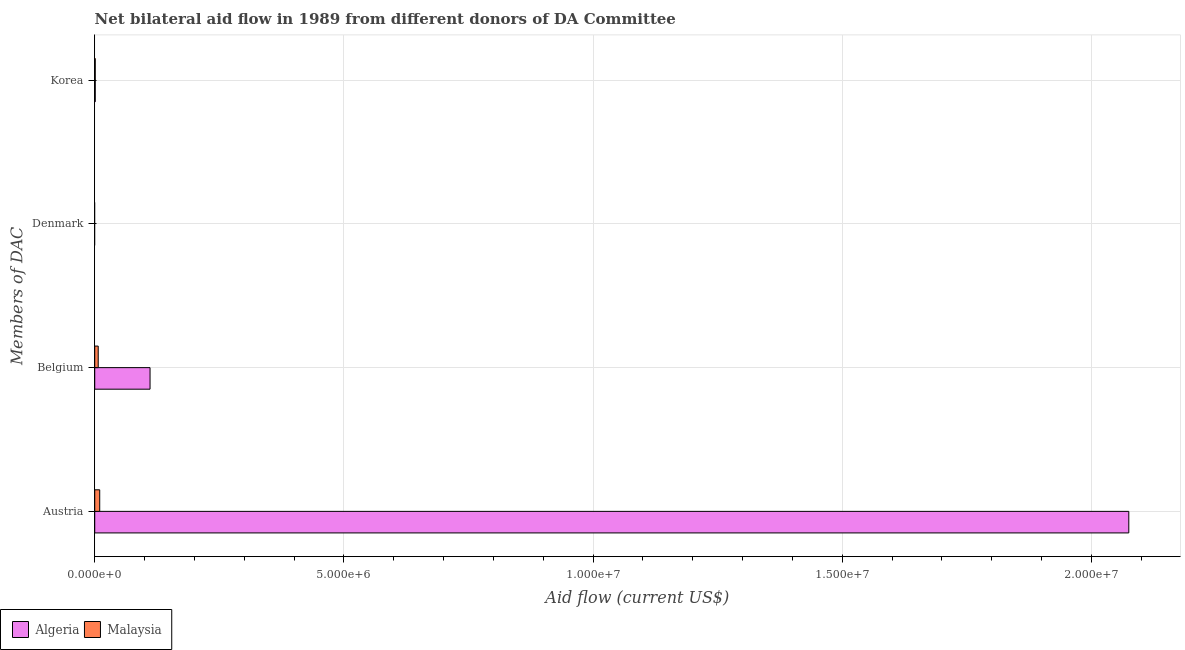How many different coloured bars are there?
Offer a very short reply. 2. Are the number of bars per tick equal to the number of legend labels?
Offer a terse response. No. Are the number of bars on each tick of the Y-axis equal?
Provide a succinct answer. No. How many bars are there on the 3rd tick from the top?
Offer a very short reply. 2. How many bars are there on the 3rd tick from the bottom?
Provide a succinct answer. 0. What is the amount of aid given by belgium in Malaysia?
Your answer should be compact. 7.00e+04. Across all countries, what is the maximum amount of aid given by korea?
Your response must be concise. 10000. Across all countries, what is the minimum amount of aid given by belgium?
Ensure brevity in your answer.  7.00e+04. In which country was the amount of aid given by korea maximum?
Keep it short and to the point. Algeria. What is the total amount of aid given by korea in the graph?
Your answer should be very brief. 2.00e+04. What is the difference between the amount of aid given by austria in Malaysia and that in Algeria?
Provide a succinct answer. -2.06e+07. What is the difference between the amount of aid given by denmark in Malaysia and the amount of aid given by austria in Algeria?
Ensure brevity in your answer.  -2.08e+07. What is the difference between the amount of aid given by belgium and amount of aid given by korea in Algeria?
Your answer should be compact. 1.10e+06. In how many countries, is the amount of aid given by korea greater than 13000000 US$?
Provide a short and direct response. 0. What is the ratio of the amount of aid given by korea in Malaysia to that in Algeria?
Provide a short and direct response. 1. Is the difference between the amount of aid given by austria in Malaysia and Algeria greater than the difference between the amount of aid given by korea in Malaysia and Algeria?
Provide a succinct answer. No. What is the difference between the highest and the second highest amount of aid given by korea?
Your answer should be very brief. 0. What is the difference between the highest and the lowest amount of aid given by belgium?
Offer a terse response. 1.04e+06. How many bars are there?
Your response must be concise. 6. Are all the bars in the graph horizontal?
Offer a very short reply. Yes. Does the graph contain any zero values?
Your answer should be compact. Yes. Does the graph contain grids?
Give a very brief answer. Yes. What is the title of the graph?
Ensure brevity in your answer.  Net bilateral aid flow in 1989 from different donors of DA Committee. What is the label or title of the Y-axis?
Offer a terse response. Members of DAC. What is the Aid flow (current US$) in Algeria in Austria?
Your answer should be very brief. 2.08e+07. What is the Aid flow (current US$) of Algeria in Belgium?
Your response must be concise. 1.11e+06. What is the Aid flow (current US$) in Algeria in Korea?
Keep it short and to the point. 10000. What is the Aid flow (current US$) in Malaysia in Korea?
Keep it short and to the point. 10000. Across all Members of DAC, what is the maximum Aid flow (current US$) of Algeria?
Your answer should be compact. 2.08e+07. Across all Members of DAC, what is the maximum Aid flow (current US$) of Malaysia?
Make the answer very short. 1.00e+05. What is the total Aid flow (current US$) in Algeria in the graph?
Your answer should be compact. 2.19e+07. What is the total Aid flow (current US$) of Malaysia in the graph?
Keep it short and to the point. 1.80e+05. What is the difference between the Aid flow (current US$) in Algeria in Austria and that in Belgium?
Keep it short and to the point. 1.96e+07. What is the difference between the Aid flow (current US$) of Malaysia in Austria and that in Belgium?
Make the answer very short. 3.00e+04. What is the difference between the Aid flow (current US$) of Algeria in Austria and that in Korea?
Offer a very short reply. 2.07e+07. What is the difference between the Aid flow (current US$) in Malaysia in Austria and that in Korea?
Provide a succinct answer. 9.00e+04. What is the difference between the Aid flow (current US$) in Algeria in Belgium and that in Korea?
Keep it short and to the point. 1.10e+06. What is the difference between the Aid flow (current US$) in Malaysia in Belgium and that in Korea?
Keep it short and to the point. 6.00e+04. What is the difference between the Aid flow (current US$) in Algeria in Austria and the Aid flow (current US$) in Malaysia in Belgium?
Offer a very short reply. 2.07e+07. What is the difference between the Aid flow (current US$) in Algeria in Austria and the Aid flow (current US$) in Malaysia in Korea?
Ensure brevity in your answer.  2.07e+07. What is the difference between the Aid flow (current US$) in Algeria in Belgium and the Aid flow (current US$) in Malaysia in Korea?
Provide a short and direct response. 1.10e+06. What is the average Aid flow (current US$) of Algeria per Members of DAC?
Ensure brevity in your answer.  5.47e+06. What is the average Aid flow (current US$) of Malaysia per Members of DAC?
Give a very brief answer. 4.50e+04. What is the difference between the Aid flow (current US$) in Algeria and Aid flow (current US$) in Malaysia in Austria?
Ensure brevity in your answer.  2.06e+07. What is the difference between the Aid flow (current US$) of Algeria and Aid flow (current US$) of Malaysia in Belgium?
Provide a succinct answer. 1.04e+06. What is the difference between the Aid flow (current US$) in Algeria and Aid flow (current US$) in Malaysia in Korea?
Give a very brief answer. 0. What is the ratio of the Aid flow (current US$) in Algeria in Austria to that in Belgium?
Make the answer very short. 18.69. What is the ratio of the Aid flow (current US$) in Malaysia in Austria to that in Belgium?
Provide a succinct answer. 1.43. What is the ratio of the Aid flow (current US$) in Algeria in Austria to that in Korea?
Provide a succinct answer. 2075. What is the ratio of the Aid flow (current US$) of Algeria in Belgium to that in Korea?
Give a very brief answer. 111. What is the ratio of the Aid flow (current US$) in Malaysia in Belgium to that in Korea?
Your answer should be very brief. 7. What is the difference between the highest and the second highest Aid flow (current US$) of Algeria?
Provide a short and direct response. 1.96e+07. What is the difference between the highest and the lowest Aid flow (current US$) of Algeria?
Give a very brief answer. 2.08e+07. 